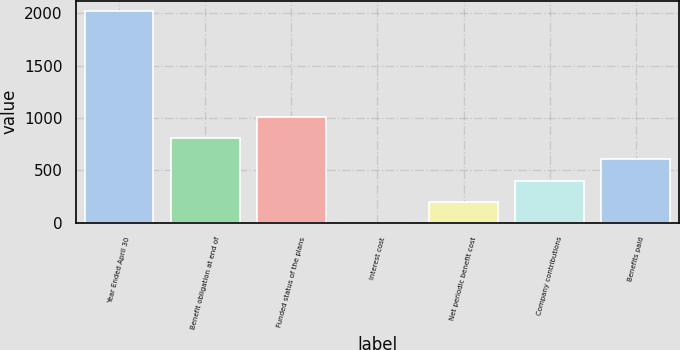Convert chart to OTSL. <chart><loc_0><loc_0><loc_500><loc_500><bar_chart><fcel>Year Ended April 30<fcel>Benefit obligation at end of<fcel>Funded status of the plans<fcel>Interest cost<fcel>Net periodic benefit cost<fcel>Company contributions<fcel>Benefits paid<nl><fcel>2018<fcel>807.38<fcel>1009.15<fcel>0.3<fcel>202.07<fcel>403.84<fcel>605.61<nl></chart> 